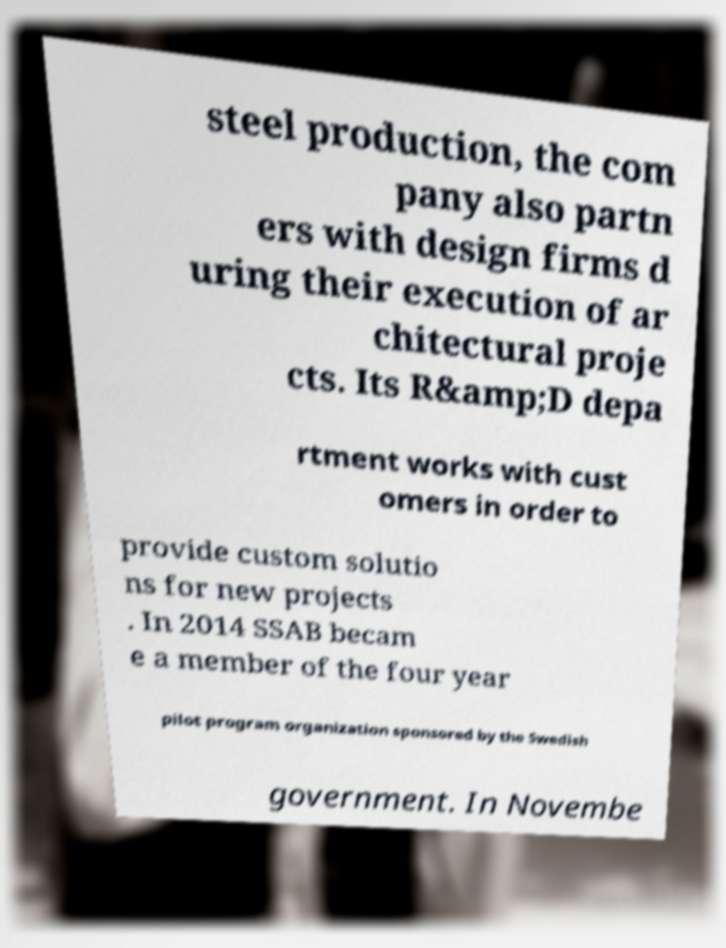Please read and relay the text visible in this image. What does it say? steel production, the com pany also partn ers with design firms d uring their execution of ar chitectural proje cts. Its R&amp;D depa rtment works with cust omers in order to provide custom solutio ns for new projects . In 2014 SSAB becam e a member of the four year pilot program organization sponsored by the Swedish government. In Novembe 